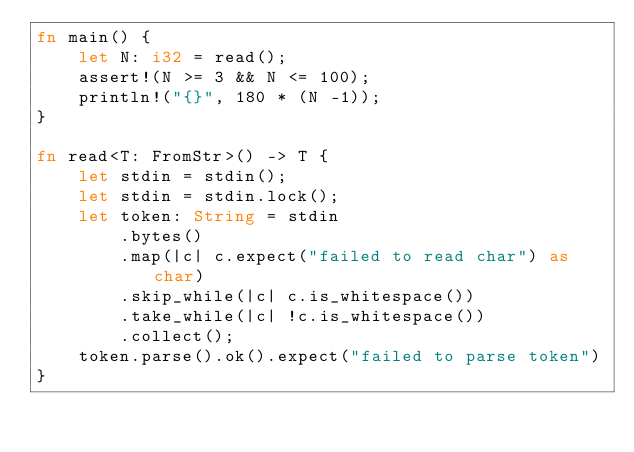Convert code to text. <code><loc_0><loc_0><loc_500><loc_500><_Rust_>fn main() {
    let N: i32 = read();
    assert!(N >= 3 && N <= 100);
    println!("{}", 180 * (N -1));
}

fn read<T: FromStr>() -> T {
    let stdin = stdin();
    let stdin = stdin.lock();
    let token: String = stdin
        .bytes()
        .map(|c| c.expect("failed to read char") as char)
        .skip_while(|c| c.is_whitespace())
        .take_while(|c| !c.is_whitespace())
        .collect();
    token.parse().ok().expect("failed to parse token")
}</code> 